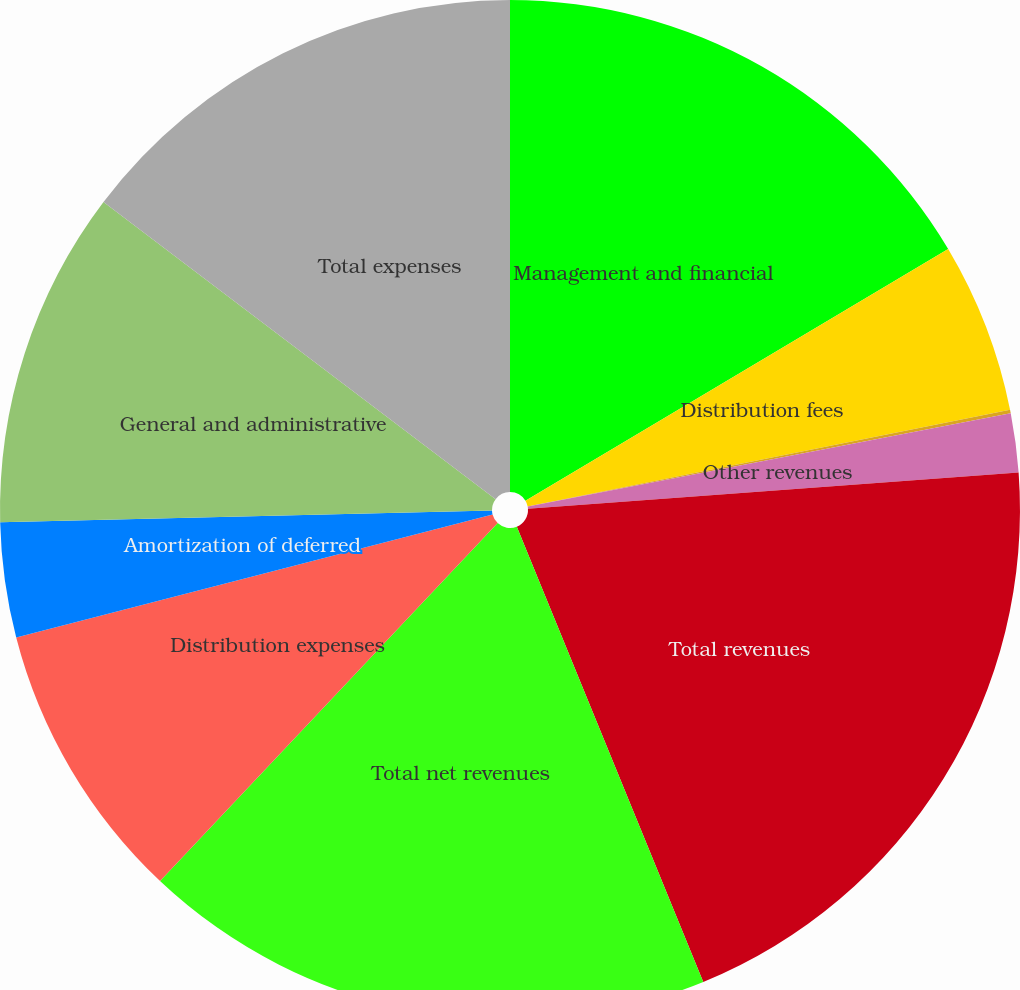<chart> <loc_0><loc_0><loc_500><loc_500><pie_chart><fcel>Management and financial<fcel>Distribution fees<fcel>Net investment income<fcel>Other revenues<fcel>Total revenues<fcel>Total net revenues<fcel>Distribution expenses<fcel>Amortization of deferred<fcel>General and administrative<fcel>Total expenses<nl><fcel>16.45%<fcel>5.4%<fcel>0.11%<fcel>1.87%<fcel>19.98%<fcel>18.22%<fcel>8.94%<fcel>3.64%<fcel>10.7%<fcel>14.68%<nl></chart> 